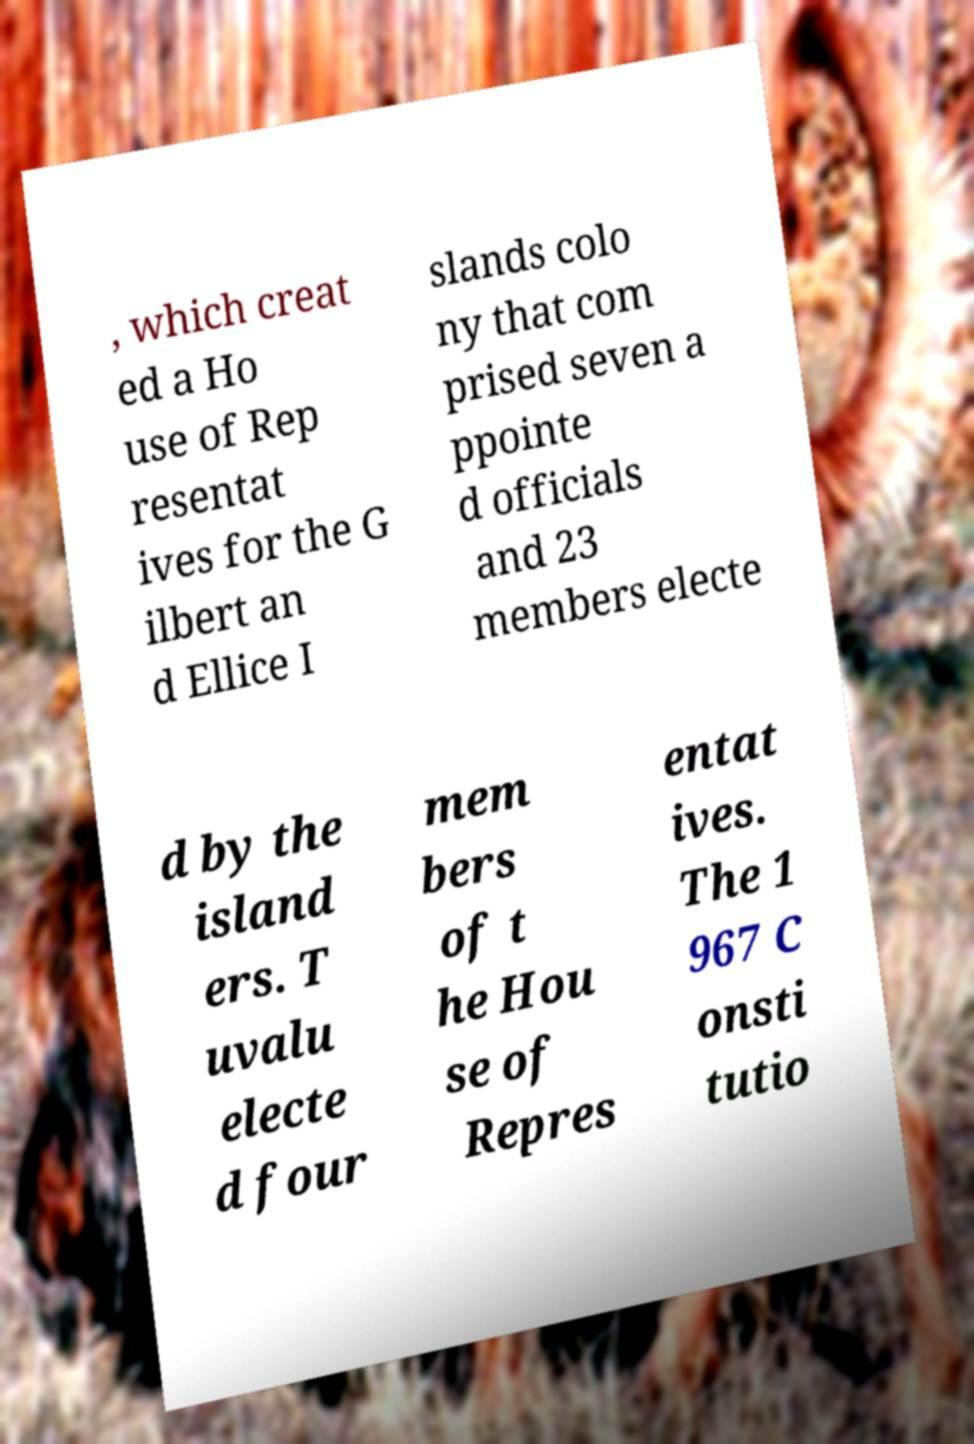Please identify and transcribe the text found in this image. , which creat ed a Ho use of Rep resentat ives for the G ilbert an d Ellice I slands colo ny that com prised seven a ppointe d officials and 23 members electe d by the island ers. T uvalu electe d four mem bers of t he Hou se of Repres entat ives. The 1 967 C onsti tutio 